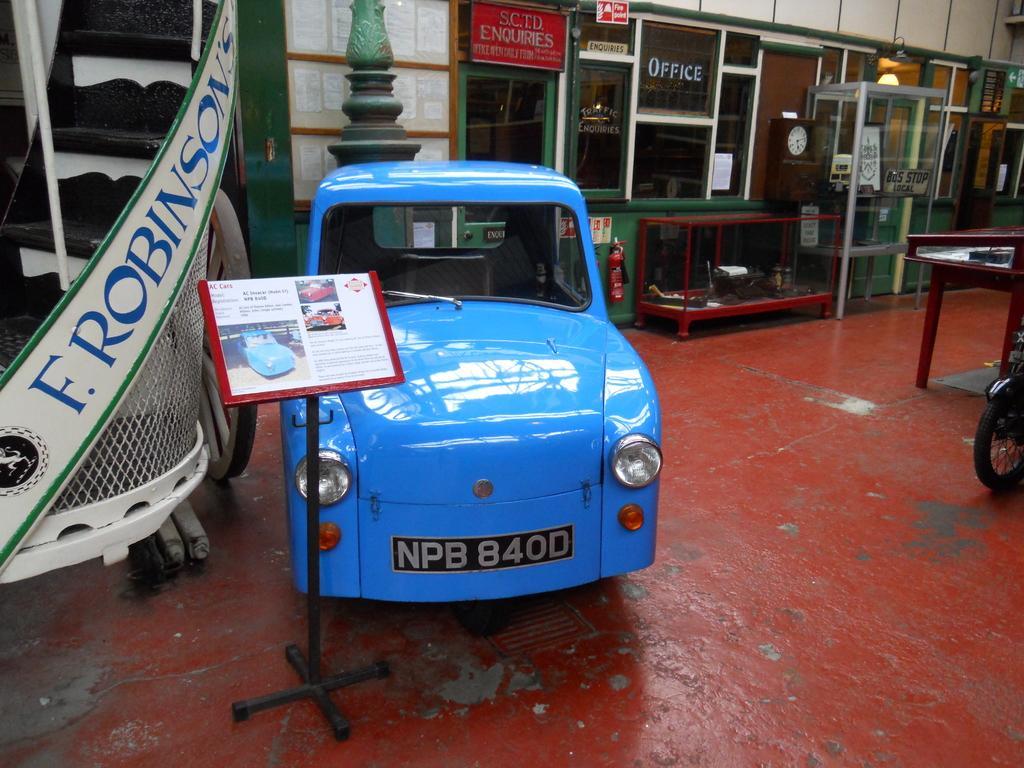Please provide a concise description of this image. In this picture I see a car and a board to the stand and a glass box and couple of tables on the left side of the picture i see stairs and few boards with text and i see a back wheel of a vehicle on the right side. 